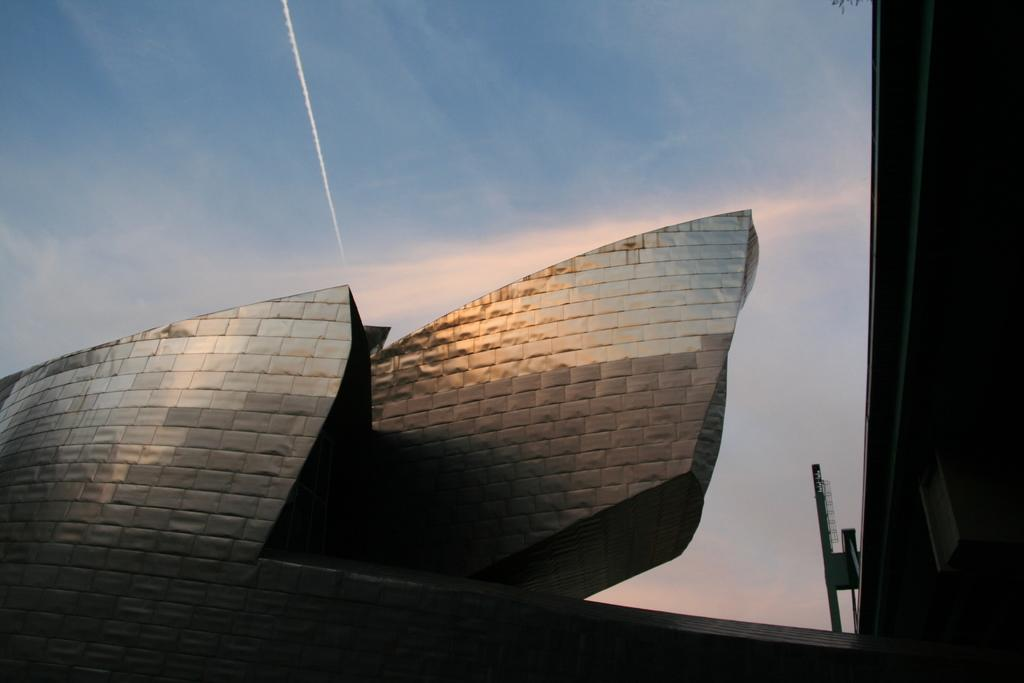What type of structure is partially visible in the image? There is a part of a building in the image. What can be seen above the building in the image? The sky is visible at the top of the image. Are there any twigs visible in the image? There are no twigs present in the image. Is this a prison or a regular building? The image does not provide enough information to determine if it is a prison or a regular building. 